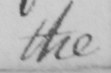Please provide the text content of this handwritten line. the 